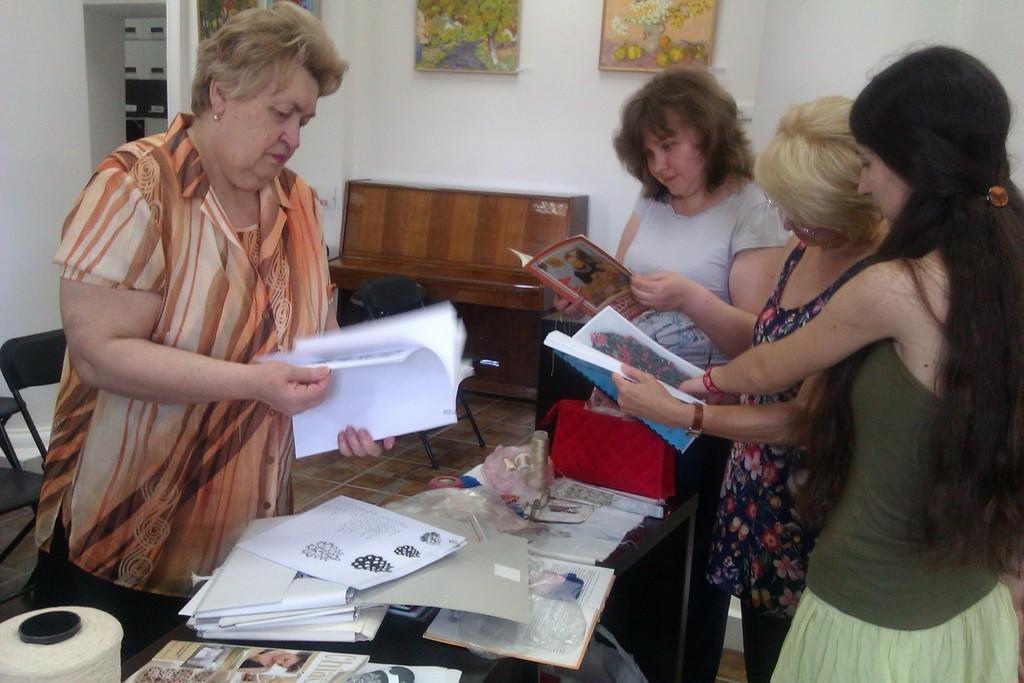Can you describe this image briefly? In this image I see 4 women who are standing and I see that these 3 women are holding books in their hands and I see a table over here on which there are many books and papers and I see a thing over here. In the background I see few chairs and I see a brown color thing over here and I see the white wall on which there are few frames. 